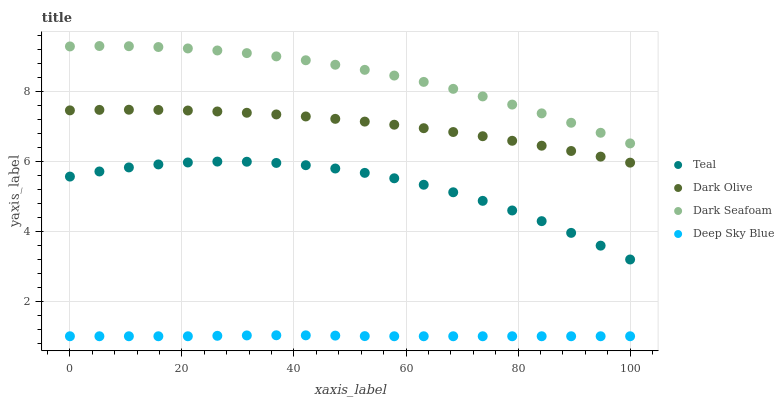Does Deep Sky Blue have the minimum area under the curve?
Answer yes or no. Yes. Does Dark Seafoam have the maximum area under the curve?
Answer yes or no. Yes. Does Dark Olive have the minimum area under the curve?
Answer yes or no. No. Does Dark Olive have the maximum area under the curve?
Answer yes or no. No. Is Deep Sky Blue the smoothest?
Answer yes or no. Yes. Is Teal the roughest?
Answer yes or no. Yes. Is Dark Olive the smoothest?
Answer yes or no. No. Is Dark Olive the roughest?
Answer yes or no. No. Does Deep Sky Blue have the lowest value?
Answer yes or no. Yes. Does Dark Olive have the lowest value?
Answer yes or no. No. Does Dark Seafoam have the highest value?
Answer yes or no. Yes. Does Dark Olive have the highest value?
Answer yes or no. No. Is Deep Sky Blue less than Dark Olive?
Answer yes or no. Yes. Is Dark Olive greater than Teal?
Answer yes or no. Yes. Does Deep Sky Blue intersect Dark Olive?
Answer yes or no. No. 